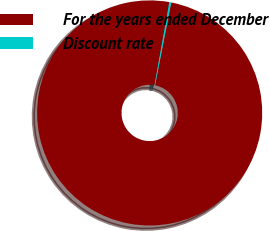<chart> <loc_0><loc_0><loc_500><loc_500><pie_chart><fcel>For the years ended December<fcel>Discount rate<nl><fcel>99.72%<fcel>0.28%<nl></chart> 